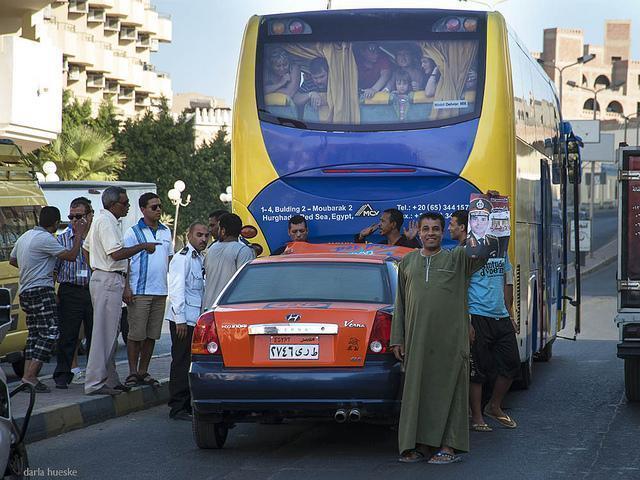What do those gathered look at here?
Select the accurate answer and provide explanation: 'Answer: answer
Rationale: rationale.'
Options: Tourists, protestors, car crash, markets. Answer: car crash.
Rationale: The car crashed into the bus. 